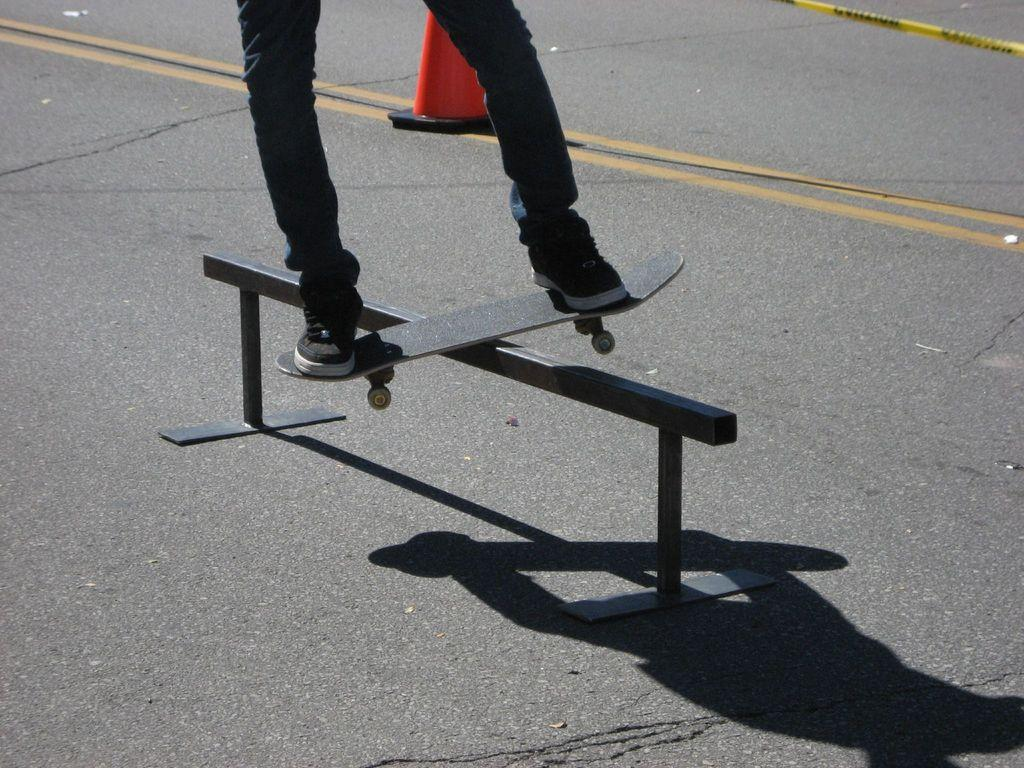What is the person doing in the image? There is a person's legs on a skateboard in the image. What is the skateboard positioned on? The skateboard is on an iron rod. What is present on the road in the image? There is a traffic cone on the road in the image. How many pizzas are being served to the crowd in the image? There are no pizzas or crowd present in the image. What type of underwear is the person wearing in the image? The image does not show the person's upper body or any underwear. 